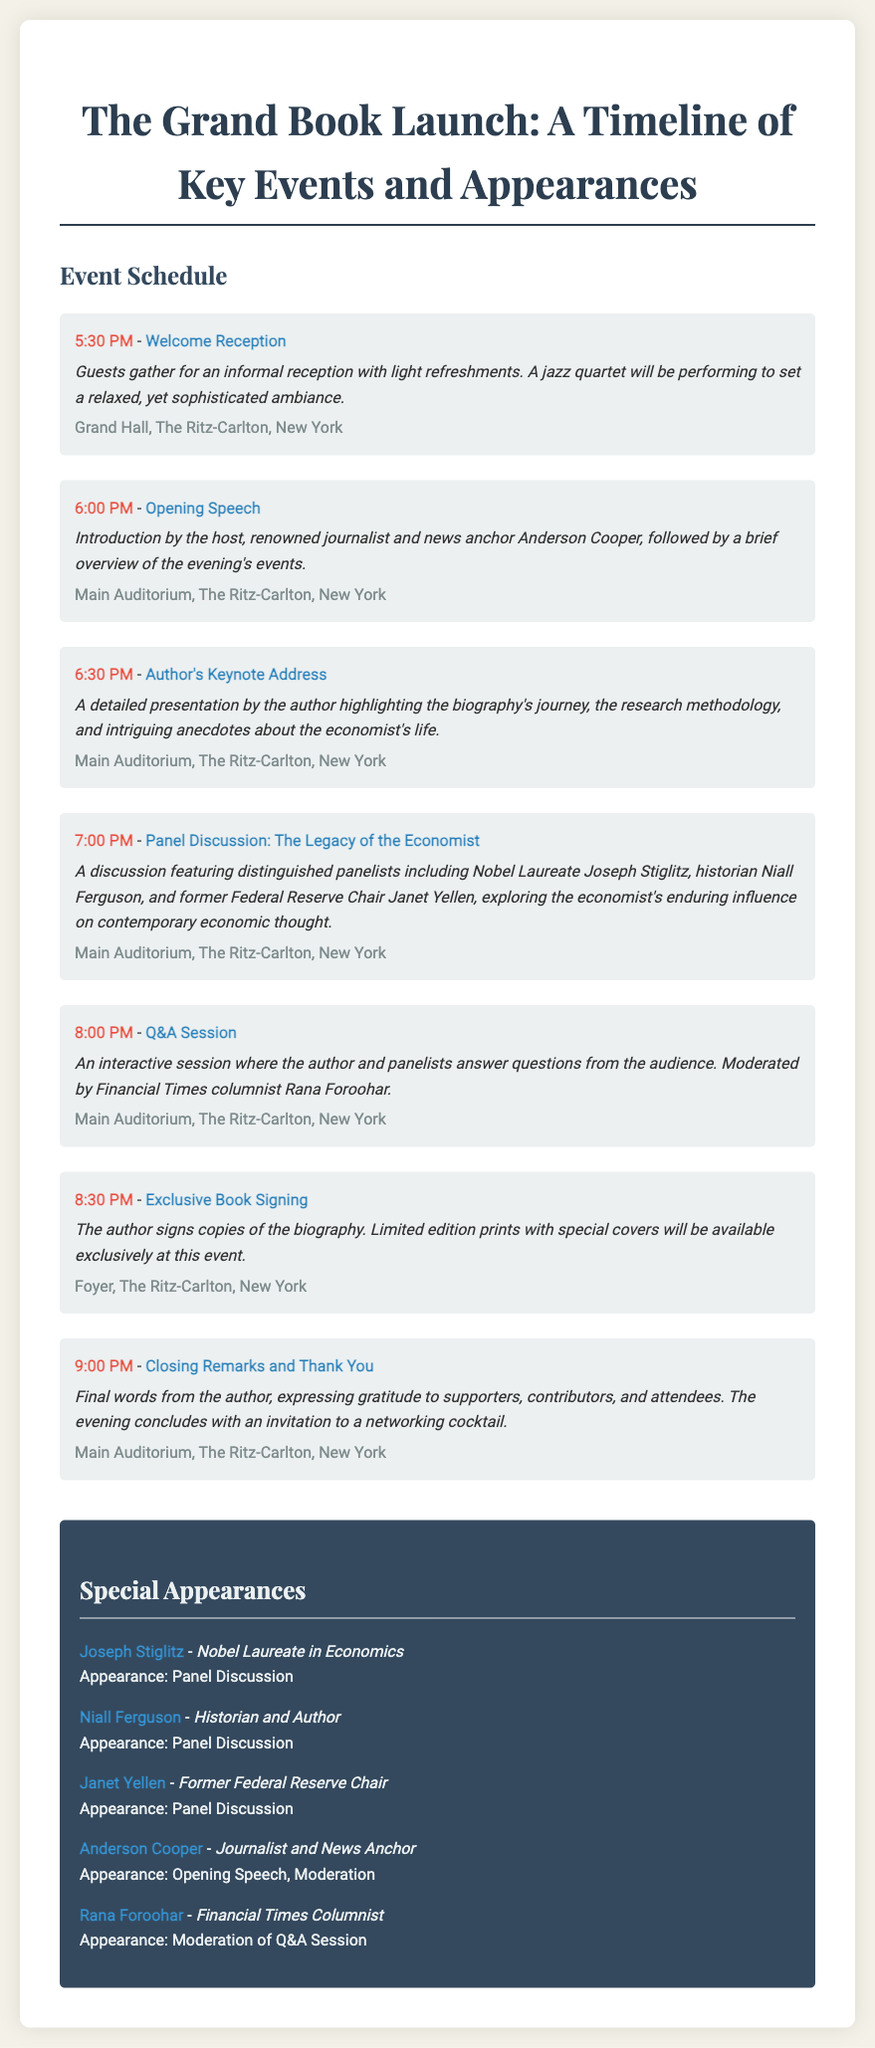What time does the Welcome Reception start? The Welcome Reception is the first event listed in the document, which shows its starting time.
Answer: 5:30 PM Who is moderating the Q&A Session? The Q&A Session's moderation is specified in the document, identifying the individual responsible for this role.
Answer: Rana Foroohar What type of performance will occur during the Welcome Reception? The information about the Welcome Reception details the kind of entertainment provided at that time.
Answer: Jazz quartet Which hall is hosting the Closing Remarks? The location for the Closing Remarks is mentioned in the document.
Answer: Main Auditorium, The Ritz-Carlton, New York How many special appearances are listed? The document provides a section exclusively for special appearances and lists the number of individuals mentioned.
Answer: Five What is the title of the discussion taking place at 7:00 PM? The document specifies the title of the event scheduled for that time, which requires retrieving this specific information.
Answer: Panel Discussion: The Legacy of the Economist Who introduces the evening's events? The document mentions who gives the opening speech, which includes introducing the subsequent events.
Answer: Anderson Cooper What will be available at the Exclusive Book Signing? The detail about the offerings during the Exclusive Book Signing highlights what attendees can expect.
Answer: Limited edition prints with special covers 